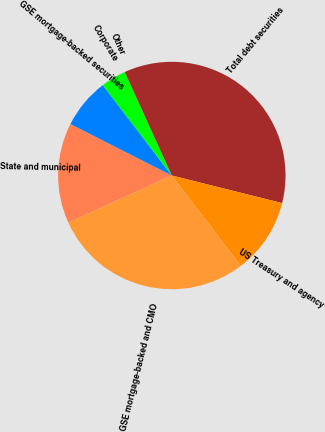Convert chart to OTSL. <chart><loc_0><loc_0><loc_500><loc_500><pie_chart><fcel>State and municipal<fcel>GSE mortgage-backed securities<fcel>Corporate<fcel>Other<fcel>Total debt securities<fcel>US Treasury and agency<fcel>GSE mortgage-backed and CMO<nl><fcel>14.28%<fcel>7.15%<fcel>3.58%<fcel>0.01%<fcel>35.69%<fcel>10.72%<fcel>28.57%<nl></chart> 